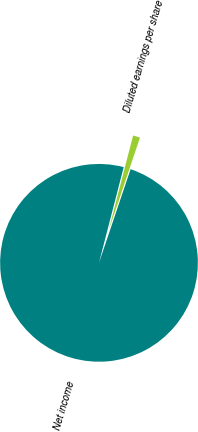Convert chart. <chart><loc_0><loc_0><loc_500><loc_500><pie_chart><fcel>Net income<fcel>Diluted earnings per share<nl><fcel>98.84%<fcel>1.16%<nl></chart> 